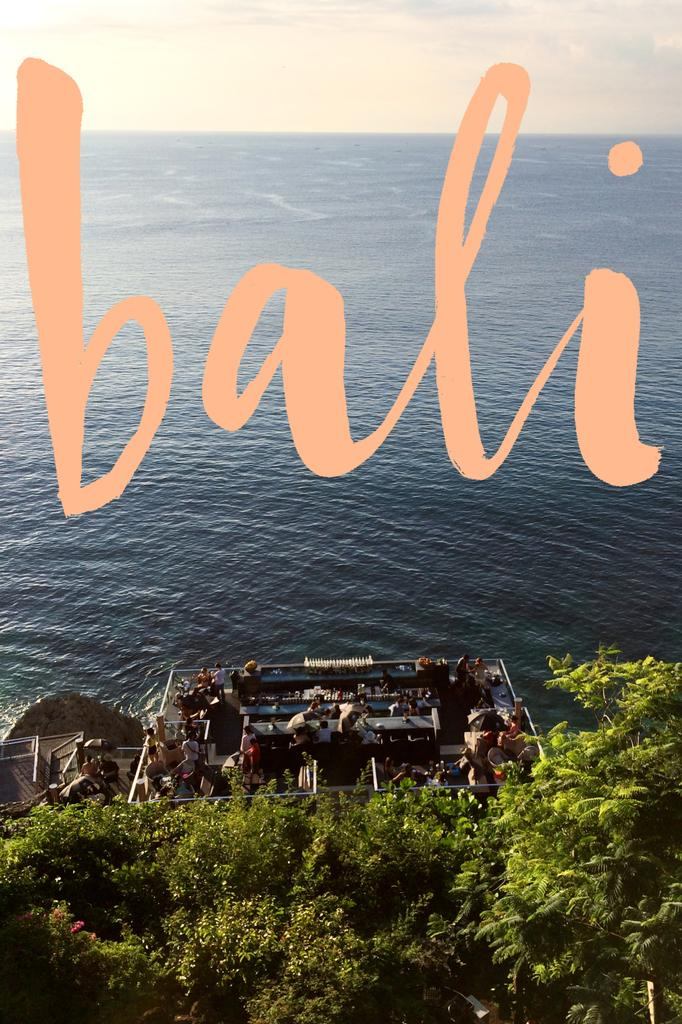Who or what can be seen in the image? There are people in the image. What type of natural environment is visible in the image? There are trees and an ocean in the image. What is visible at the top of the image? The sky is visible at the top of the image. Can you describe any additional features in the image? There is a watermark in the middle of the image. What type of wax can be seen melting on the people in the image? There is no wax present in the image, and therefore no such activity can be observed. 